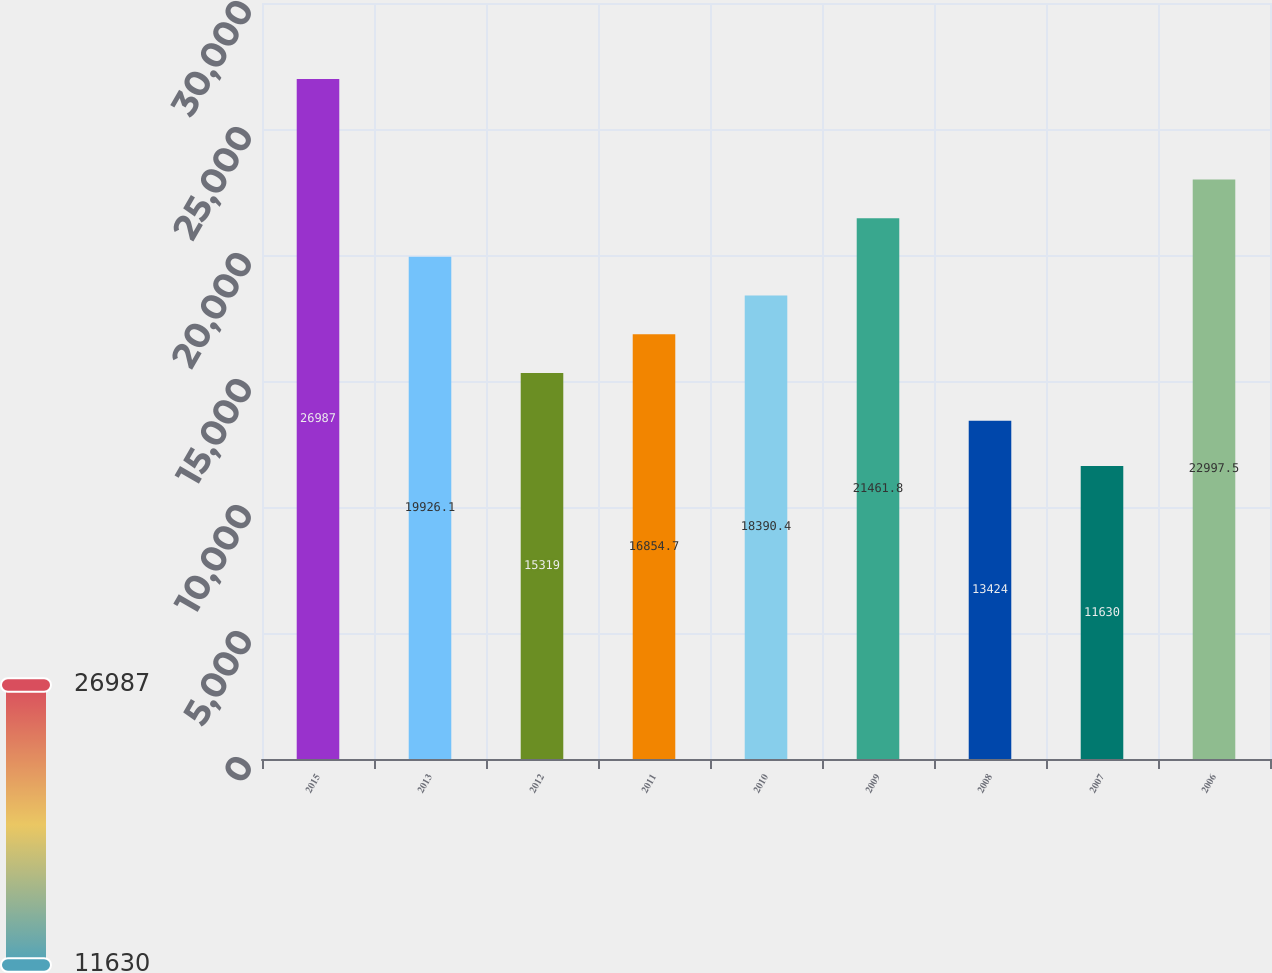Convert chart to OTSL. <chart><loc_0><loc_0><loc_500><loc_500><bar_chart><fcel>2015<fcel>2013<fcel>2012<fcel>2011<fcel>2010<fcel>2009<fcel>2008<fcel>2007<fcel>2006<nl><fcel>26987<fcel>19926.1<fcel>15319<fcel>16854.7<fcel>18390.4<fcel>21461.8<fcel>13424<fcel>11630<fcel>22997.5<nl></chart> 